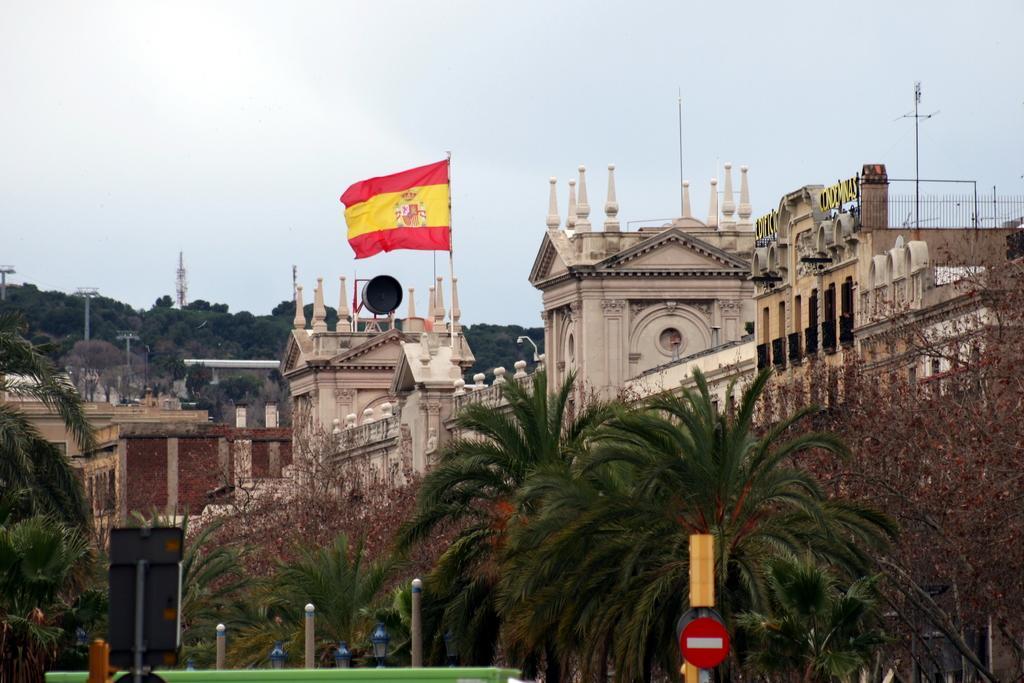Could you give a brief overview of what you see in this image? In this picture we can see buildings, trees, metal poles and some objects, here we can see a flag, electric poles and we can see sky in the background. 